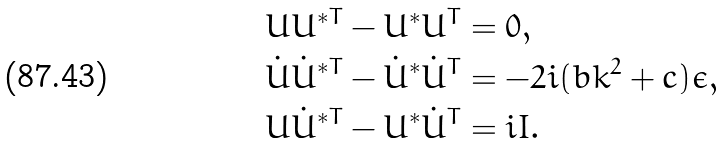Convert formula to latex. <formula><loc_0><loc_0><loc_500><loc_500>& U U ^ { \ast T } - U ^ { \ast } U ^ { T } = 0 , \\ & { \dot { U } } { \dot { U } } ^ { \ast T } - { \dot { U } } ^ { \ast } { \dot { U } } ^ { T } = - 2 i ( b k ^ { 2 } + c ) \epsilon , \\ & U { \dot { U } } ^ { \ast T } - U ^ { \ast } { \dot { U } } ^ { T } = i I .</formula> 